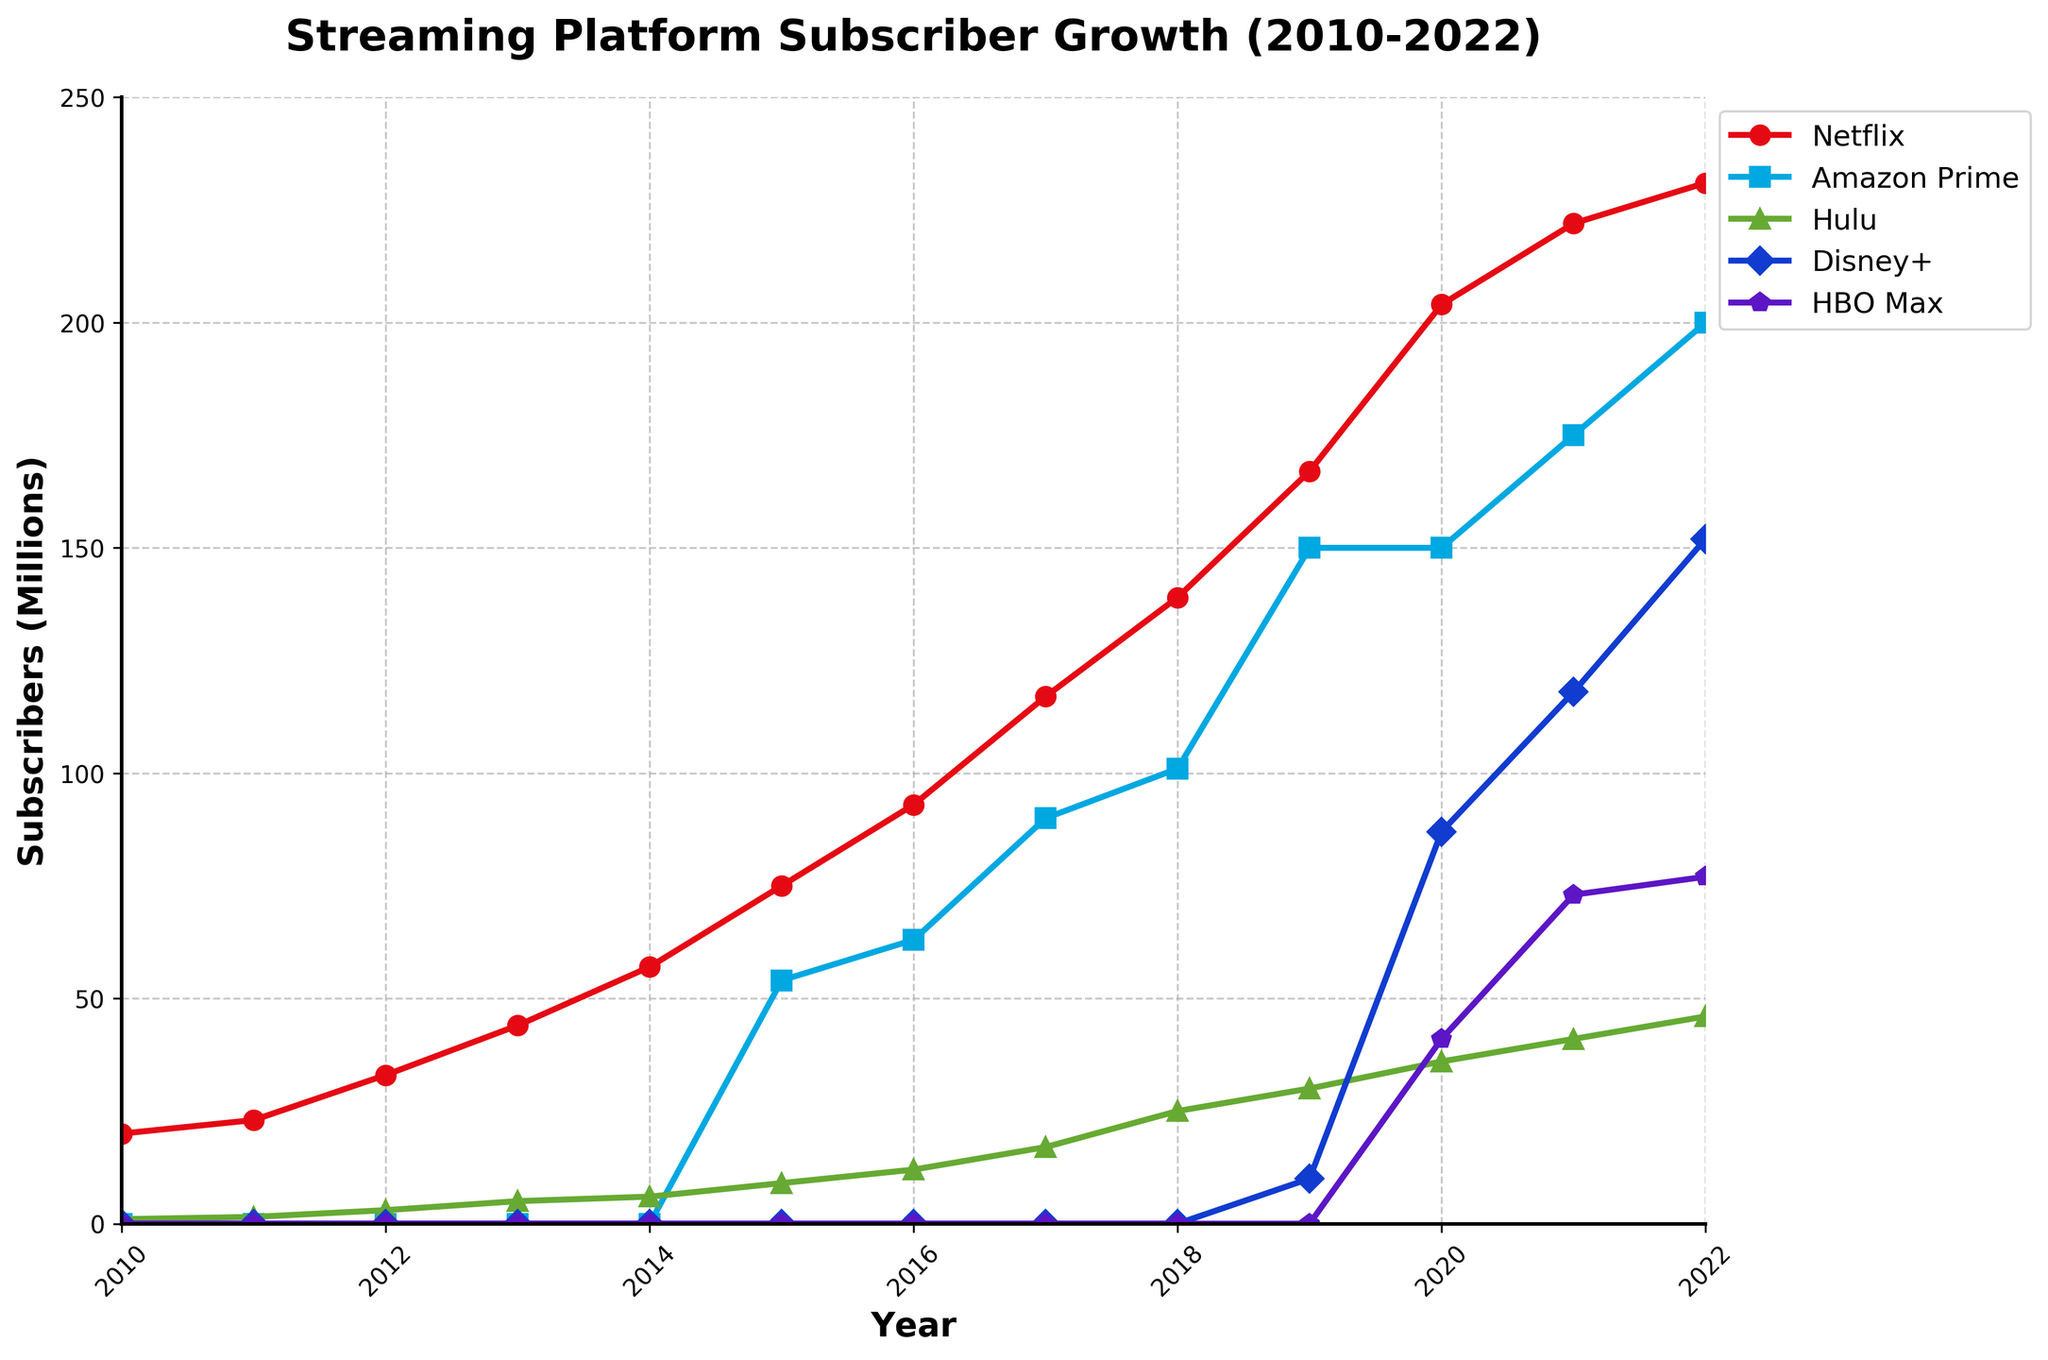what year did Disney+ start showing significant subscriber growth? Looking at the figure, Disney+ starts showing significant subscriber growth from the year 2020 where it jumps from 10 million in 2019 to 87 million in 2020.
Answer: 2020 Which streaming platform had the highest number of subscribers in 2022? By examining the heights of the lines in 2022, Netflix has the highest number with 231 million subscribers.
Answer: Netflix Compare the subscriber growth of Hulu and HBO Max in 2021. In 2021, Hulu had 41 million subscribers, and HBO Max had 73 million subscribers. HBO Max has more subscribers compared to Hulu in that year.
Answer: HBO Max What is the color of the line representing Netflix in the chart? The line representing Netflix is visually red in the chart.
Answer: red Which platform saw the biggest increase in subscribers from 2019 to 2020? By looking at the change from 2019 to 2020, Disney+ increased from 10 million to 87 million subscribers, a difference of 77 million, which is the biggest increase among the platforms.
Answer: Disney+ By how many millions did Amazon Prime's subscribers increase from 2011 to the year it first appears on the chart? Amazon Prime first appears in the chart in 2015 with 54 million subscribers. Since it had 0 subscribers in 2011, the increase is 54 - 0 = 54 million.
Answer: 54 What is the average number of subscribers for HBO Max from 2020 to 2022? The subscriber counts for HBO Max from 2020 to 2022 are 41, 73, and 77 respectively. Calculate the average as (41 + 73 + 77) / 3 = 191 / 3 ≈ 63.67 million.
Answer: 63.67 Which platforms have almost parallel growth patterns between 2016 and 2018? By observing the slope of the lines between 2016 and 2018, Amazon Prime and Hulu exhibit almost parallel growth patterns.
Answer: Amazon Prime and Hulu 